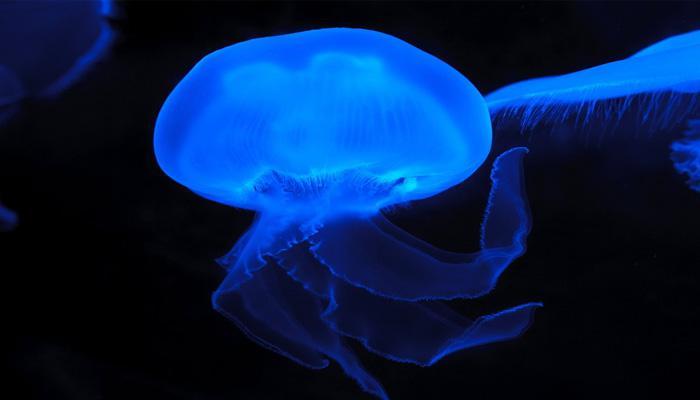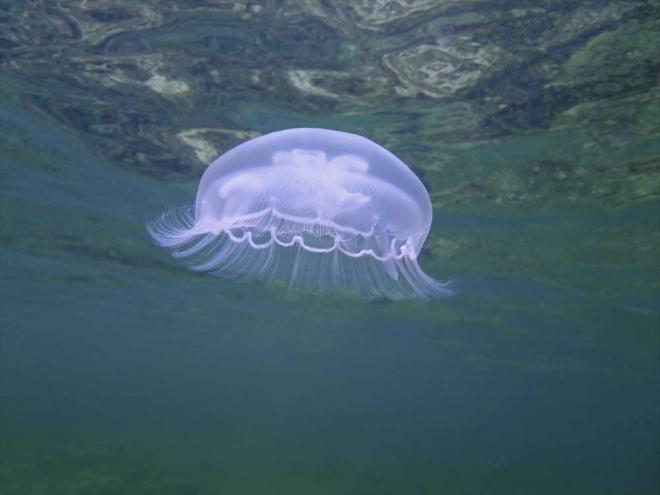The first image is the image on the left, the second image is the image on the right. Given the left and right images, does the statement "One organism is on the bottom." hold true? Answer yes or no. No. The first image is the image on the left, the second image is the image on the right. Evaluate the accuracy of this statement regarding the images: "One image shows a single upside-down beige jellyfish with short tentacles extending upward from a saucer-shaped 'cap', and the other image shows a glowing yellowish jellyfish with long stringy tentacles trailing down from a dome 'cap'.". Is it true? Answer yes or no. No. 